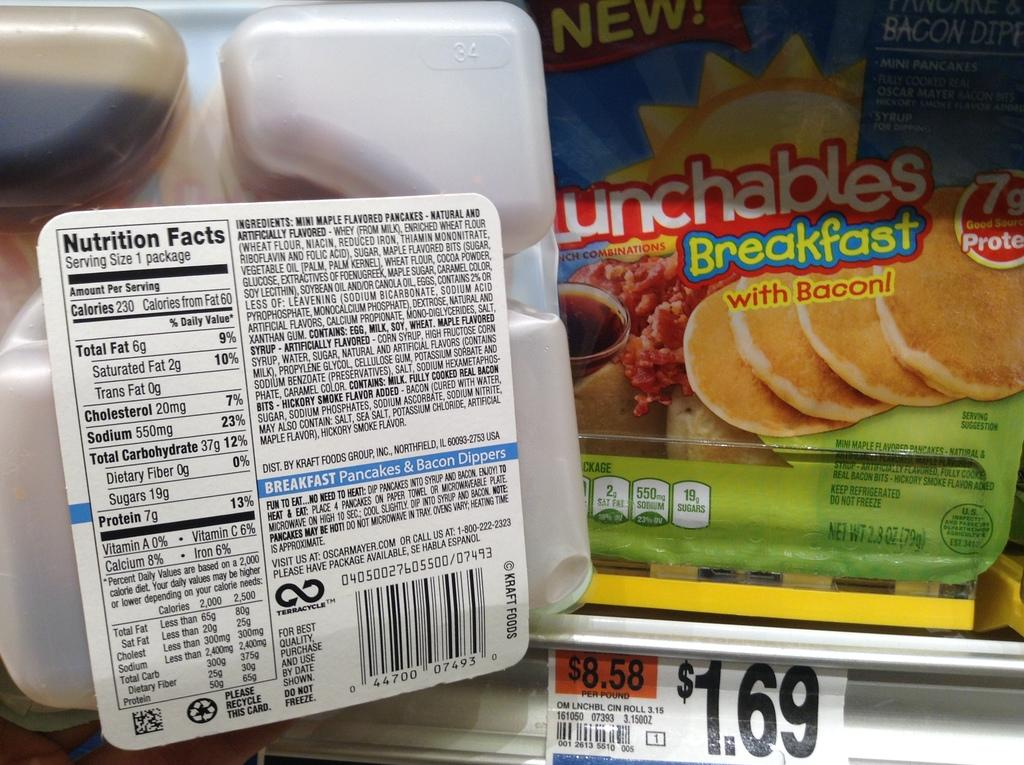What type of items can be seen in the image? There are food packets in the image. Is there any information about the cost of the items? Yes, there is a price tag in the image. What type of noise can be heard coming from the river in the image? There is no river present in the image, so it's not possible to determine what type of noise might be heard. 